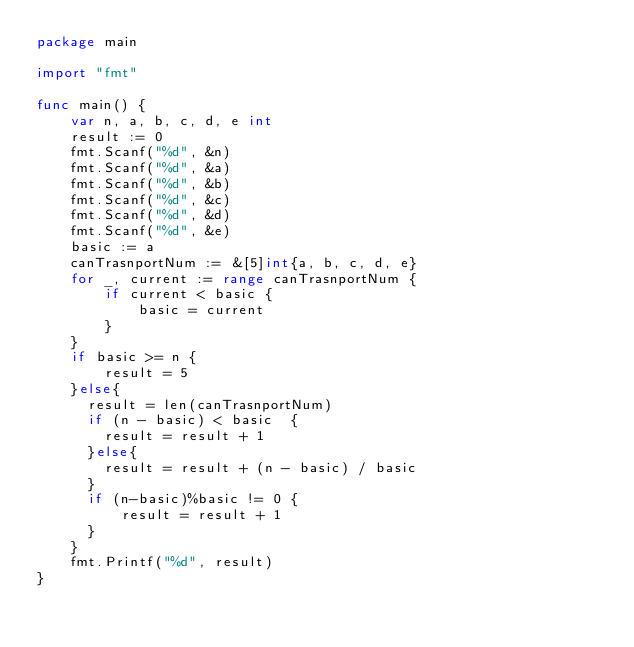<code> <loc_0><loc_0><loc_500><loc_500><_Go_>package main

import "fmt"

func main() {
	var n, a, b, c, d, e int
	result := 0
	fmt.Scanf("%d", &n)
	fmt.Scanf("%d", &a)
	fmt.Scanf("%d", &b)
	fmt.Scanf("%d", &c)
	fmt.Scanf("%d", &d)
	fmt.Scanf("%d", &e)
  	basic := a
	canTrasnportNum := &[5]int{a, b, c, d, e}
	for _, current := range canTrasnportNum {
		if current < basic {
			basic = current
		}
	}
    if basic >= n {
		result = 5
    }else{
  	  result = len(canTrasnportNum)
      if (n - basic) < basic  {
        result = result + 1
      }else{
        result = result + (n - basic) / basic
      }
      if (n-basic)%basic != 0 {
          result = result + 1
      }	
    }
    fmt.Printf("%d", result)
}
</code> 